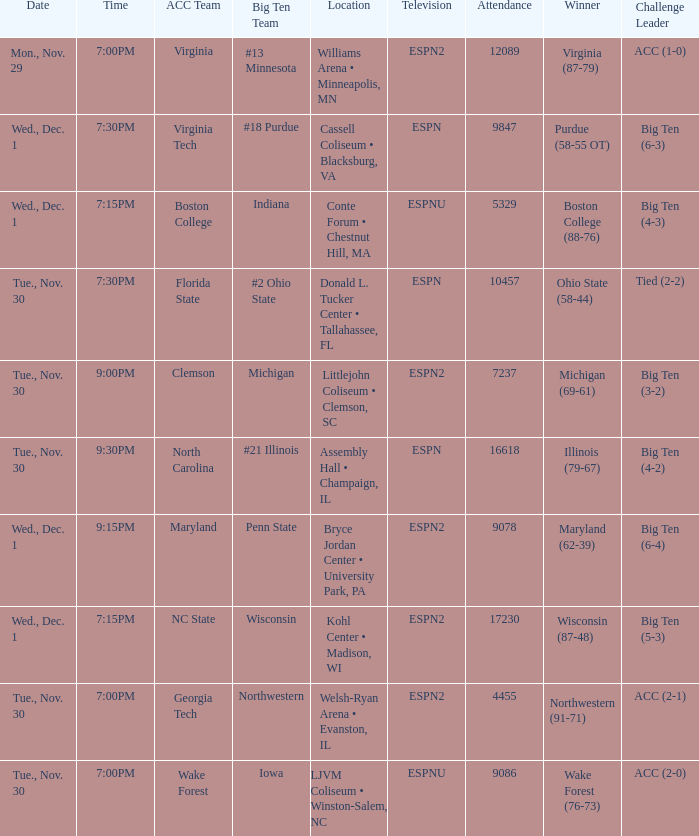Where did the games that had Wake Forest as Acc Team take place? LJVM Coliseum • Winston-Salem, NC. 